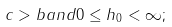Convert formula to latex. <formula><loc_0><loc_0><loc_500><loc_500>c > b a n d 0 \leq h _ { 0 } < \infty ;</formula> 